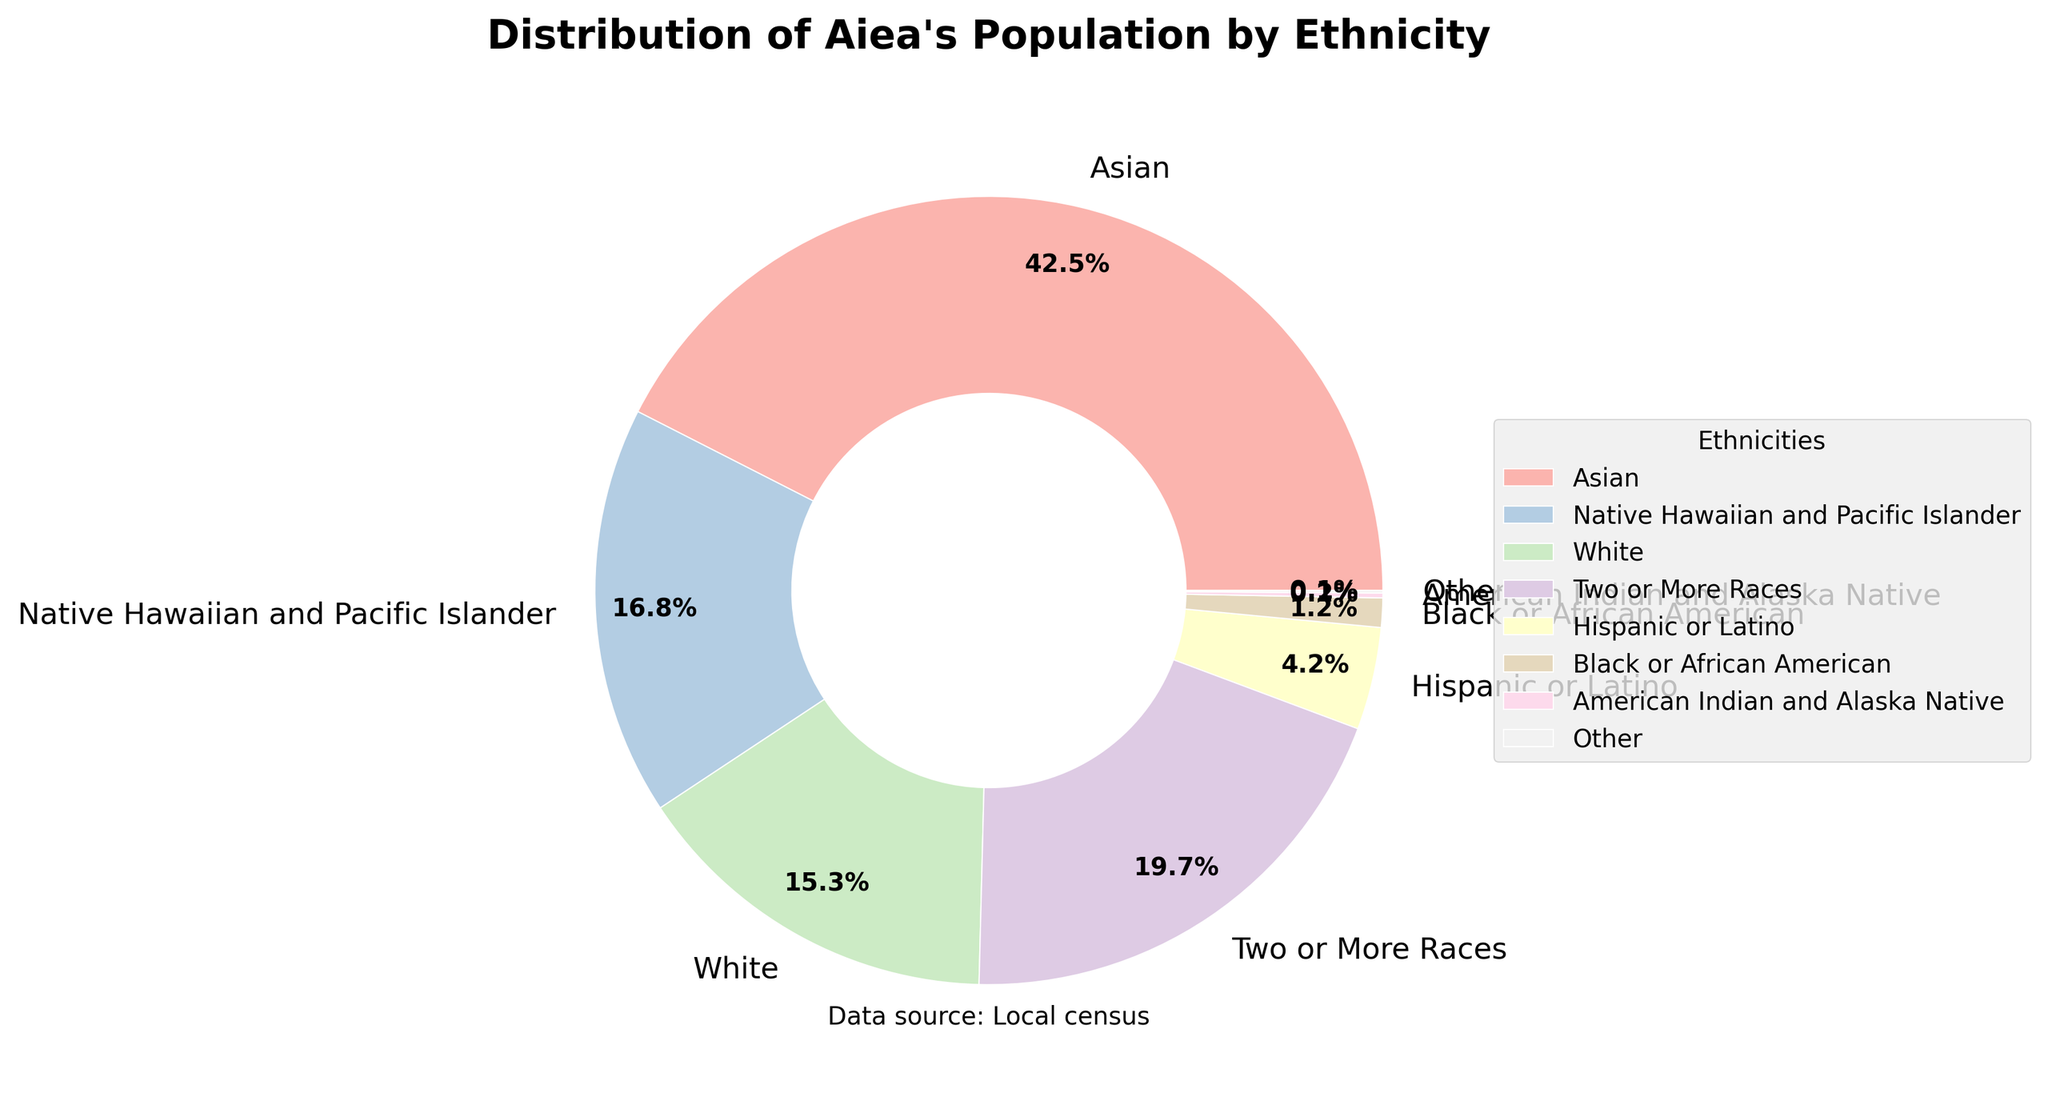What ethnicity has the largest population percentage in Aiea? The pie chart shows that the Asian ethnicity has the largest portion of the pie. From the data, we know the percentage is 42.5%.
Answer: Asian What is the combined percentage of Native Hawaiian and Pacific Islander, and Two or More Races? Add the percentages for Native Hawaiian and Pacific Islander (16.8%) and Two or More Races (19.7%). 16.8% + 19.7% = 36.5%.
Answer: 36.5% Which ethnicity has a smaller population percentage, White or Hispanic or Latino? From the pie chart, we can see that the White ethnicity has a percentage of 15.3% while Hispanic or Latino has 4.2%. 4.2% is less than 15.3%.
Answer: Hispanic or Latino What is the percentage difference between the Asian population and the Black or African American population in Aiea? Subtract the percentage of Black or African American (1.2%) from the percentage of Asian (42.5%). 42.5% - 1.2% = 41.3%.
Answer: 41.3% What percentage of the population is made up of groups with less than 5% each? Add the percentages for Hispanic or Latino (4.2%), Black or African American (1.2%), American Indian and Alaska Native (0.2%), and Other (0.1%). 4.2% + 1.2% + 0.2% + 0.1% = 5.7%.
Answer: 5.7% How does the percentage of Two or More Races compare with Native Hawaiian and Pacific Islander? The pie chart indicates that Two or More Races has a percentage of 19.7% whereas Native Hawaiian and Pacific Islander have 16.8%. Since 19.7% is greater than 16.8%, Two or More Races has a higher percentage.
Answer: Two or More Races have a higher percentage Which ethnicity has the smallest representation in Aiea's population, and what is the percentage? The pie chart shows that 'Other' has the smallest segment. From the data, the percentage is 0.1%.
Answer: Other, 0.1% What can you say about the proportions of the White and Two or More Races ethnicities in the population? The pie chart shows that the White ethnicity has a smaller segment compared to Two or More Races. The data reveals that the White population is 15.3% while Two or More Races is 19.7%.
Answer: Two or More Races is larger than White 